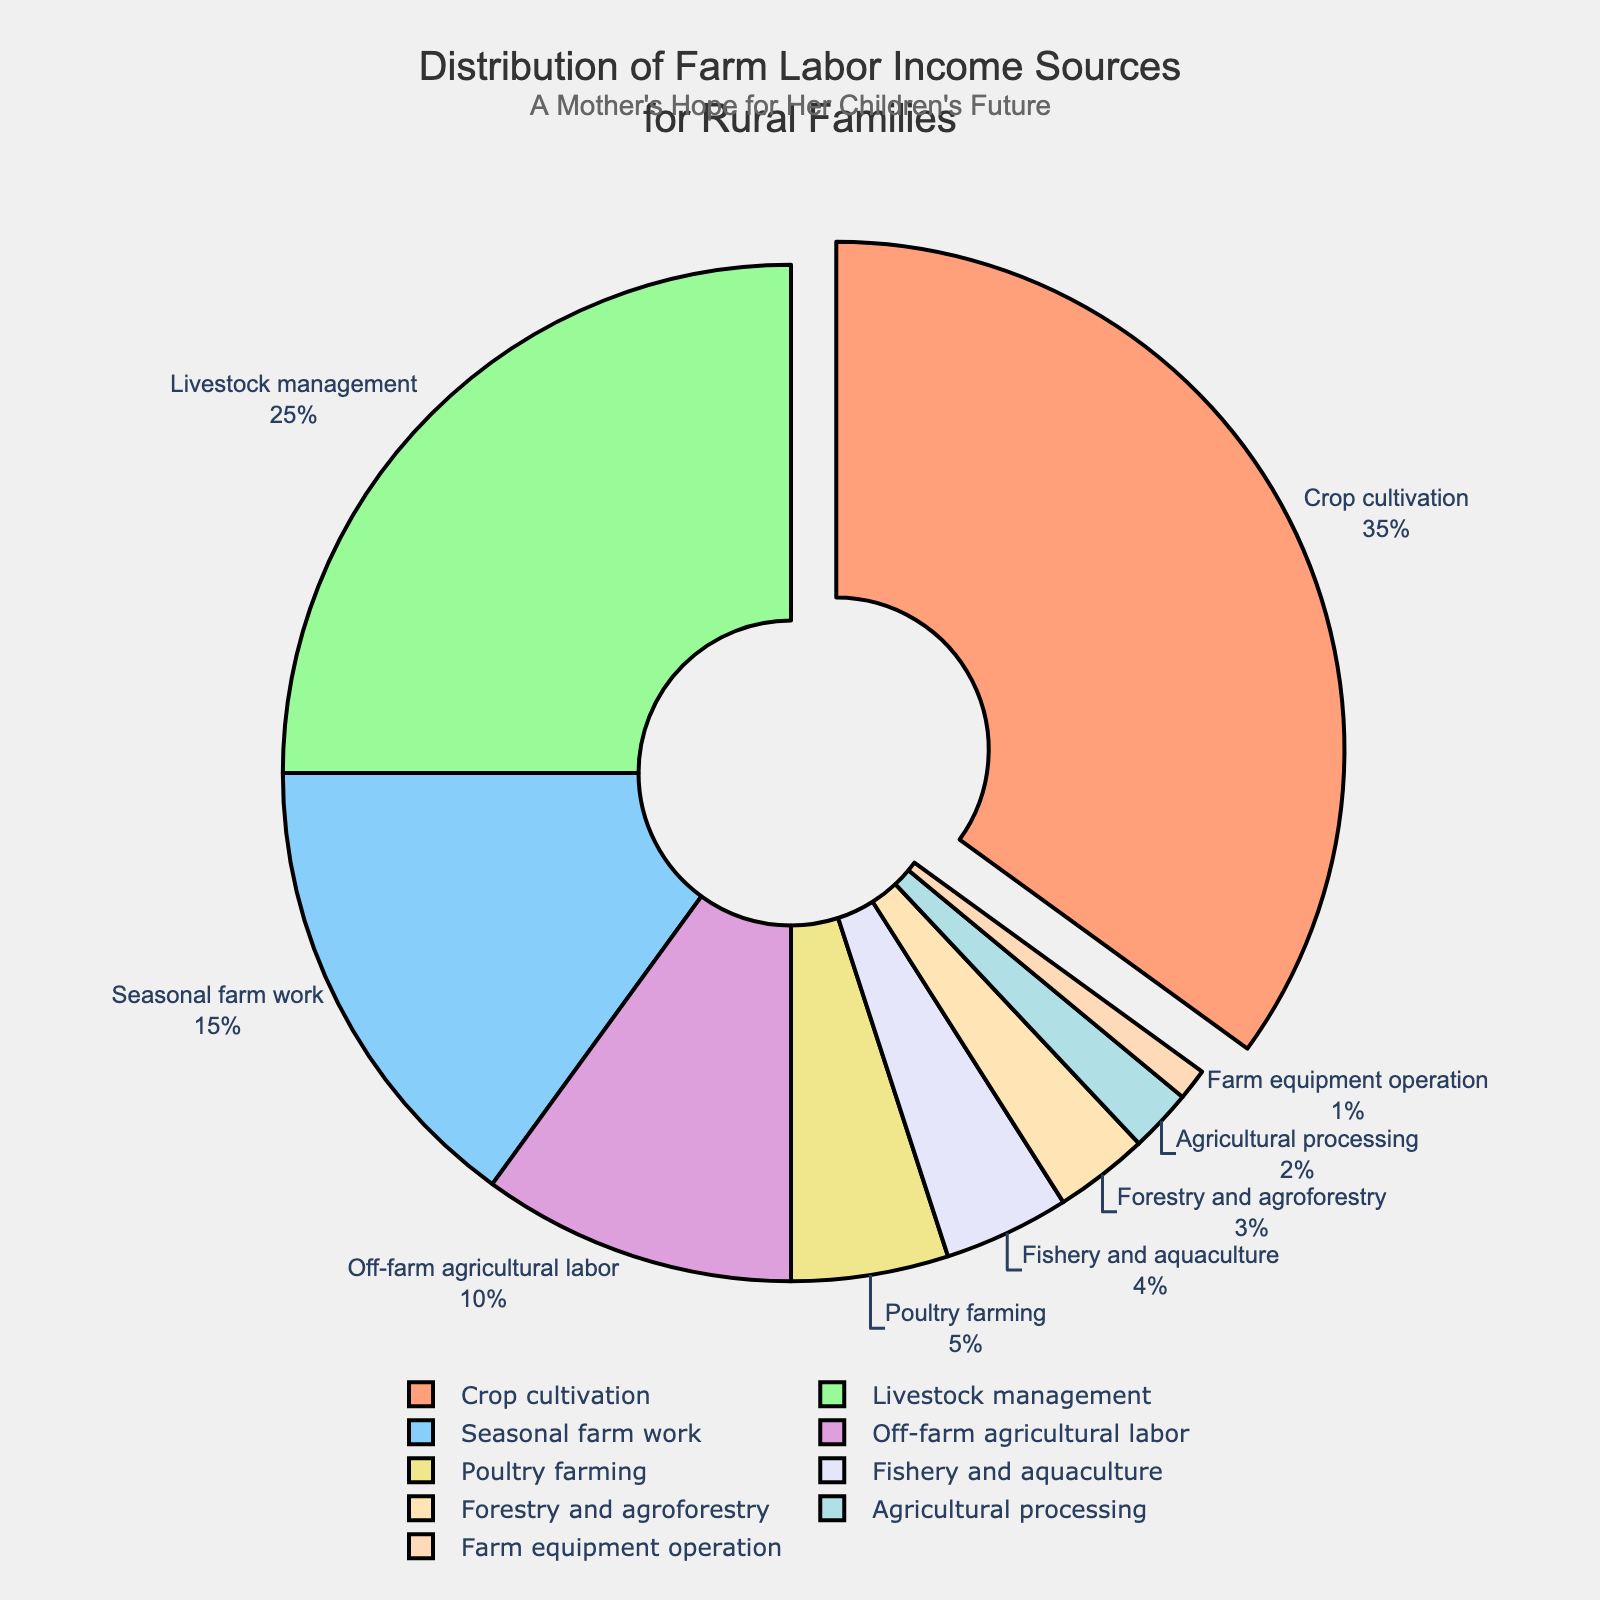Which category contributes the most to farm labor income? Crop cultivation is labeled with 35%, which is the highest proportion compared to other categories.
Answer: Crop cultivation How much more income percentage does Crop cultivation contribute compared to Livestock management? Crop cultivation’s percentage (35%) minus Livestock management’s percentage (25%) results in 10%.
Answer: 10% Which categories together make up at least 50% of the farm labor income? Crop cultivation (35%) and Livestock management (25%) together contribute 35% + 25% = 60%. This is more than 50%.
Answer: Crop cultivation and Livestock management Which category has the smallest contribution to farm labor income? Farm equipment operation is marked with 1%, which is the smallest percentage in the chart.
Answer: Farm equipment operation What is the combined percentage of income from Seasonal farm work and Off-farm agricultural labor? Seasonal farm work contributes 15% and Off-farm agricultural labor contributes 10%; together they sum up to 15% + 10% = 25%.
Answer: 25% Compare the income percentage from Fishery and aquaculture to Forestry and agroforestry. Which is greater? Fishery and aquaculture has 4%, while Forestry and agroforestry has 3%. 4% is greater than 3%.
Answer: Fishery and aquaculture If you add the percentages from Agricultural processing and Poultry farming, do they exceed Seasonal farm work's contribution? Agricultural processing (2%) plus Poultry farming (5%) equals 7%, which is less than Seasonal farm work’s 15%.
Answer: No What can be inferred from the text position and size of the Crop cultivation label? Crop cultivation’s label is positioned outside the chart and pulled out noticeably, indicating it has the highest value. Its text is also clearly visible due to its separation.
Answer: Highest value How many categories contribute less than 5% each to the farm labor income? Fishery and aquaculture (4%), Forestry and agroforestry (3%), Agricultural processing (2%), and Farm equipment operation (1%) each contribute less than 5%. That's four categories.
Answer: 4 